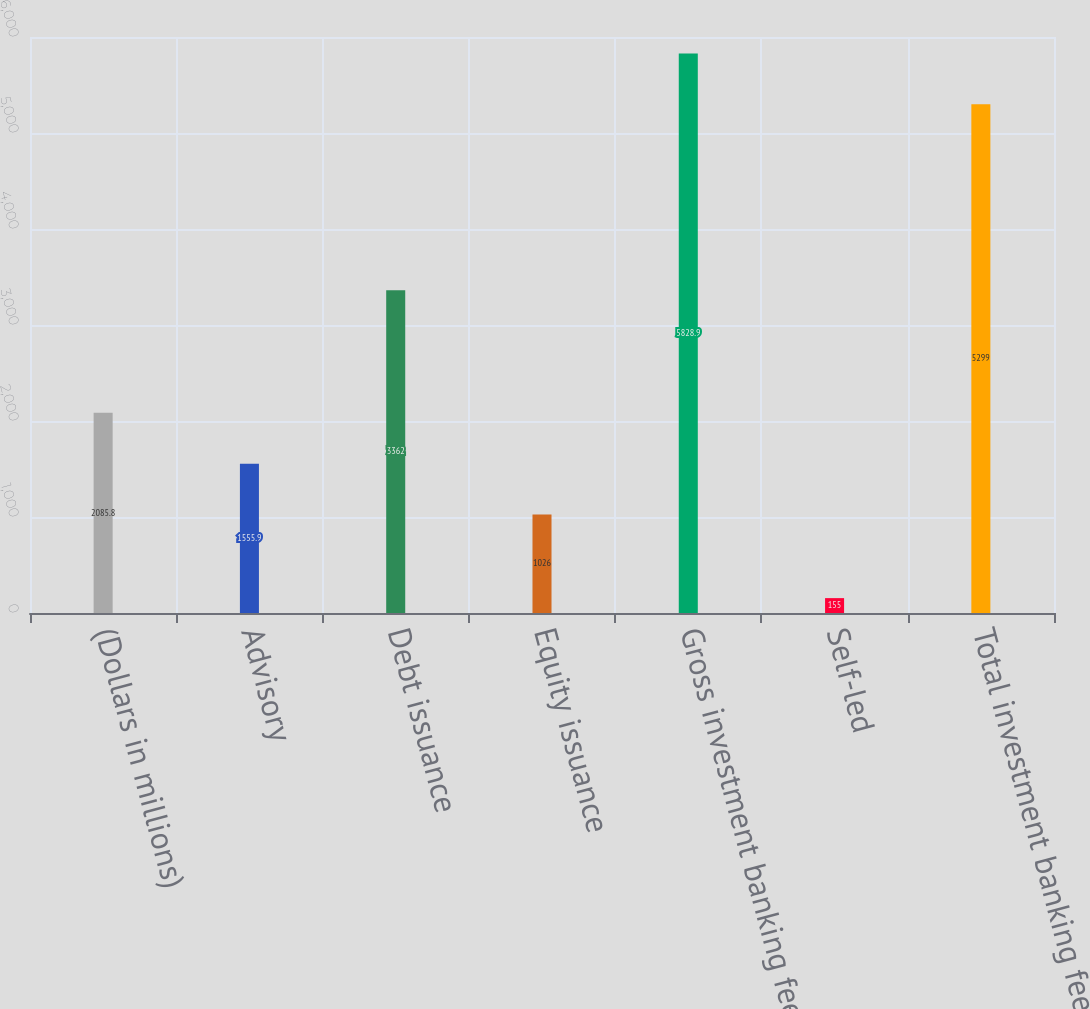Convert chart. <chart><loc_0><loc_0><loc_500><loc_500><bar_chart><fcel>(Dollars in millions)<fcel>Advisory<fcel>Debt issuance<fcel>Equity issuance<fcel>Gross investment banking fees<fcel>Self-led<fcel>Total investment banking fees<nl><fcel>2085.8<fcel>1555.9<fcel>3362<fcel>1026<fcel>5828.9<fcel>155<fcel>5299<nl></chart> 